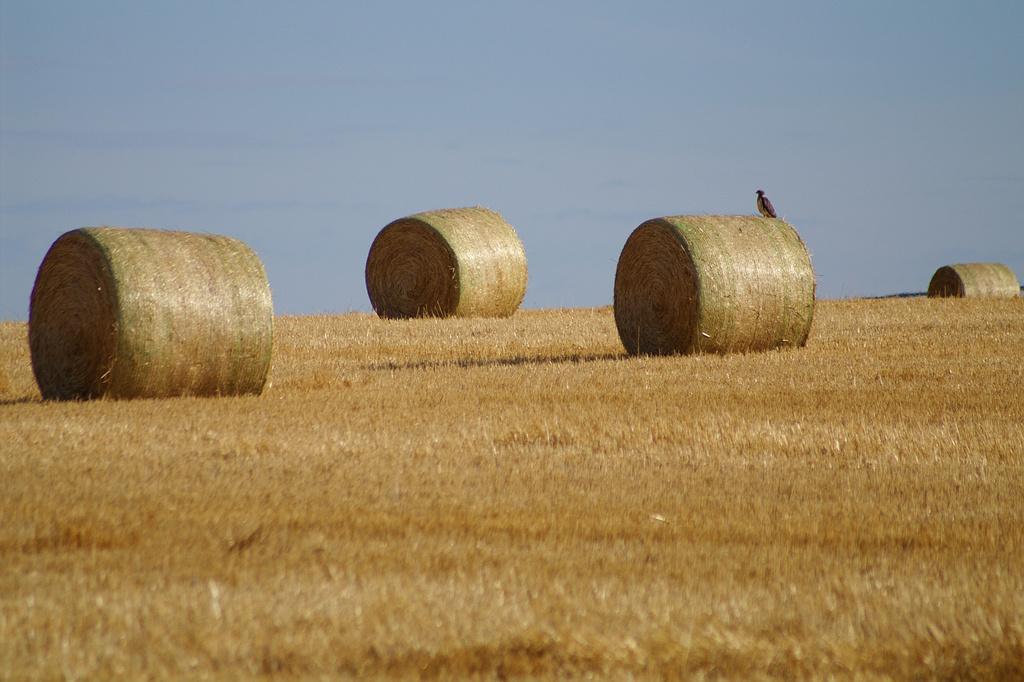Describe this image in one or two sentences. In this image we can see dry grass, hay and a bird on it and the pale blue color sky in the background. 